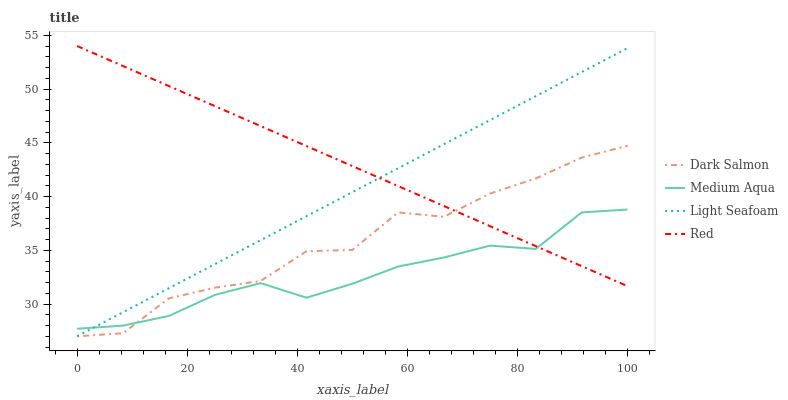Does Medium Aqua have the minimum area under the curve?
Answer yes or no. Yes. Does Red have the maximum area under the curve?
Answer yes or no. Yes. Does Dark Salmon have the minimum area under the curve?
Answer yes or no. No. Does Dark Salmon have the maximum area under the curve?
Answer yes or no. No. Is Red the smoothest?
Answer yes or no. Yes. Is Dark Salmon the roughest?
Answer yes or no. Yes. Is Medium Aqua the smoothest?
Answer yes or no. No. Is Medium Aqua the roughest?
Answer yes or no. No. Does Medium Aqua have the lowest value?
Answer yes or no. No. Does Dark Salmon have the highest value?
Answer yes or no. No. 